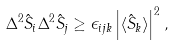<formula> <loc_0><loc_0><loc_500><loc_500>\Delta ^ { 2 } \hat { S } _ { i } \Delta ^ { 2 } \hat { S } _ { j } \geq \epsilon _ { i j k } \left | \langle \hat { S } _ { k } \rangle \right | ^ { 2 } ,</formula> 